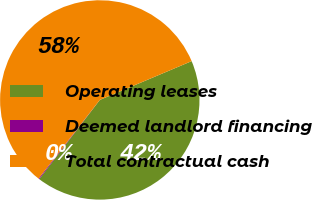Convert chart to OTSL. <chart><loc_0><loc_0><loc_500><loc_500><pie_chart><fcel>Operating leases<fcel>Deemed landlord financing<fcel>Total contractual cash<nl><fcel>41.75%<fcel>0.14%<fcel>58.11%<nl></chart> 